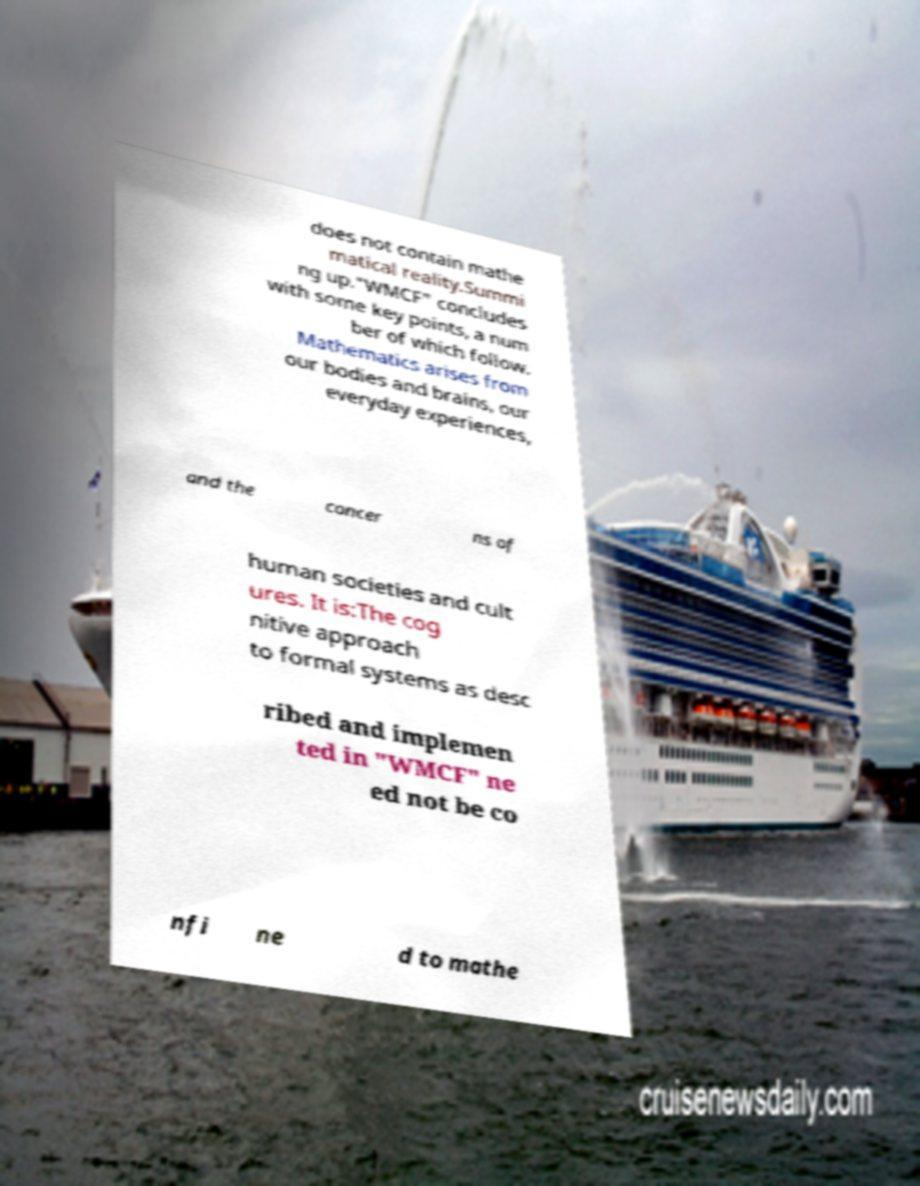There's text embedded in this image that I need extracted. Can you transcribe it verbatim? does not contain mathe matical reality.Summi ng up."WMCF" concludes with some key points, a num ber of which follow. Mathematics arises from our bodies and brains, our everyday experiences, and the concer ns of human societies and cult ures. It is:The cog nitive approach to formal systems as desc ribed and implemen ted in "WMCF" ne ed not be co nfi ne d to mathe 